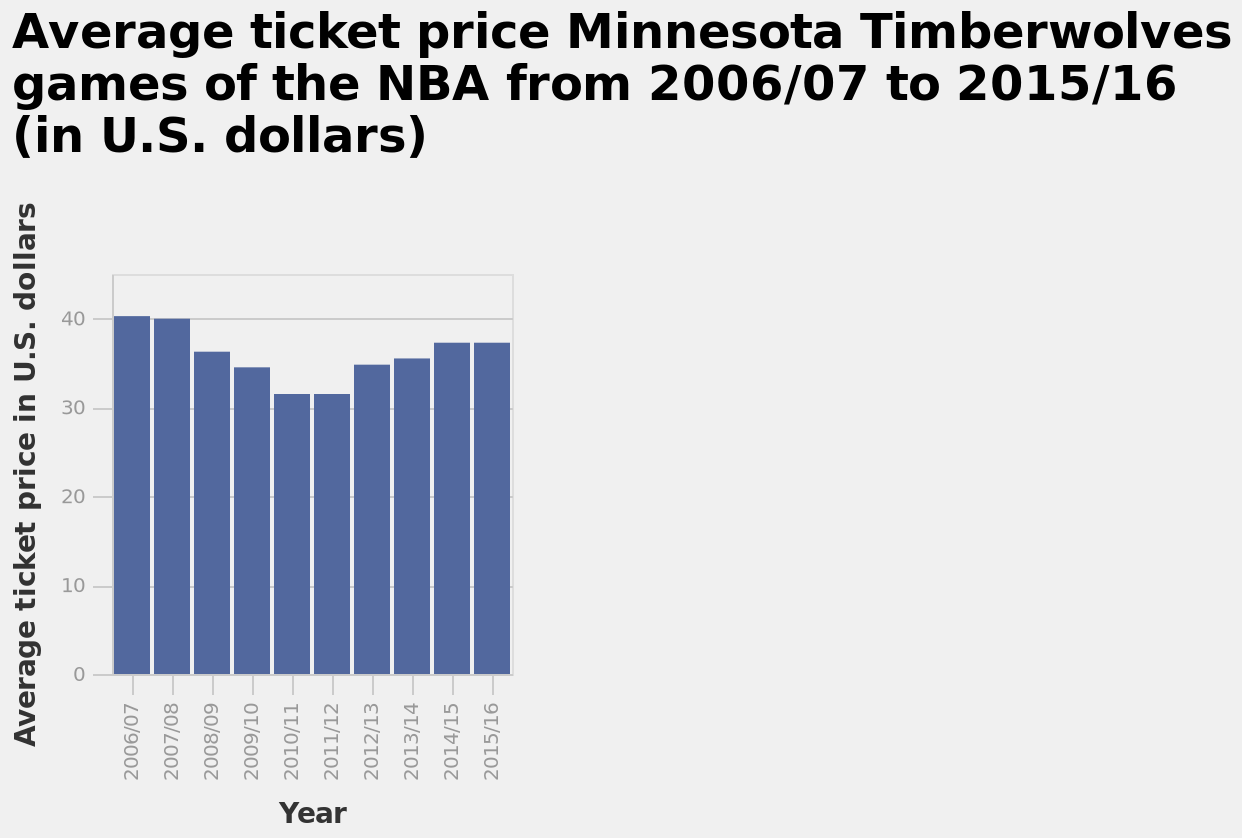<image>
Were there any fluctuations in ticket prices between 10/11 and 14/15? No, ticket prices remained the same for a year before gradually increasing from 12/13 to 14/15. In which currency are the ticket prices presented in this chart? The ticket prices in this chart are presented in U.S. dollars. Did ticket prices increase or decrease from 10/11 to 14/15? Ticket prices gradually increased from 10/11 to 14/15. What is the subject of this bar chart?  The subject of this bar chart is the Average ticket price of Minnesota Timberwolves games of the NBA. Is the subject of this pie chart the Average ticket price of Minnesota Timberwolves games of the NBA? No. The subject of this bar chart is the Average ticket price of Minnesota Timberwolves games of the NBA. 